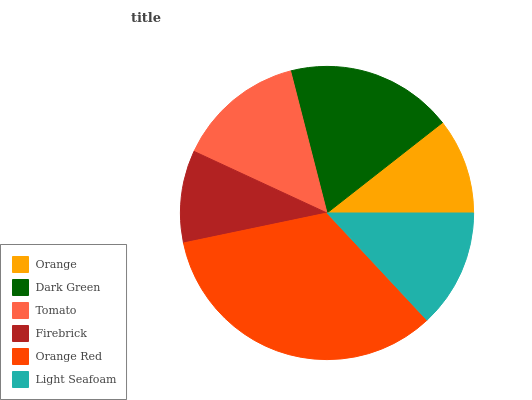Is Firebrick the minimum?
Answer yes or no. Yes. Is Orange Red the maximum?
Answer yes or no. Yes. Is Dark Green the minimum?
Answer yes or no. No. Is Dark Green the maximum?
Answer yes or no. No. Is Dark Green greater than Orange?
Answer yes or no. Yes. Is Orange less than Dark Green?
Answer yes or no. Yes. Is Orange greater than Dark Green?
Answer yes or no. No. Is Dark Green less than Orange?
Answer yes or no. No. Is Tomato the high median?
Answer yes or no. Yes. Is Light Seafoam the low median?
Answer yes or no. Yes. Is Firebrick the high median?
Answer yes or no. No. Is Orange the low median?
Answer yes or no. No. 